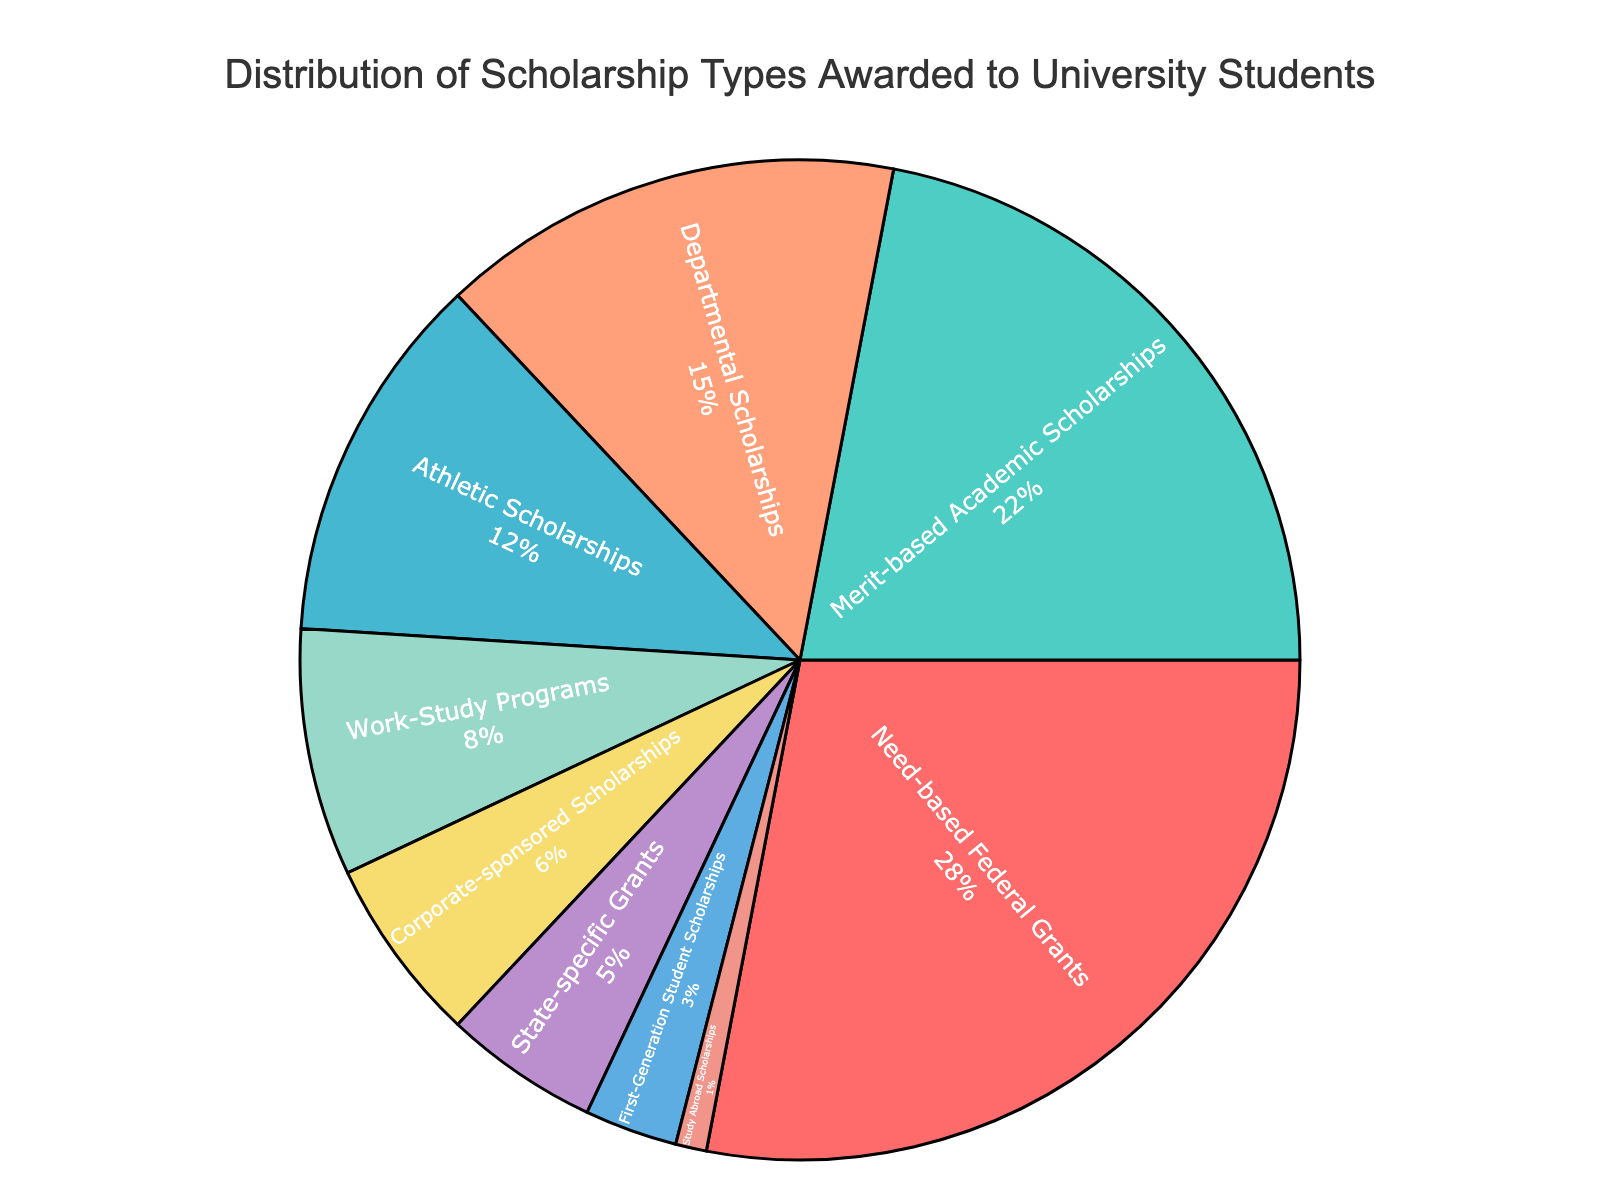What percentage of the scholarships are awarded as Need-based Federal Grants? The segment labeled "Need-based Federal Grants" shows 28% in the pie chart.
Answer: 28% Which scholarship type is the smallest in terms of percentage? The smallest segment in the pie chart is "Study Abroad Scholarships" at 1%.
Answer: Study Abroad Scholarships How much more percentage of scholarships are awarded as Merit-based Academic Scholarships compared to Athletic Scholarships? Merit-based Academic Scholarships are 22%, and Athletic Scholarships are 12%. The difference is 22% - 12% = 10%.
Answer: 10% Which scholarship types together make up exactly half of the total scholarships? Need-based Federal Grants (28%) plus Merit-based Academic Scholarships (22%) sum up to 50%.
Answer: Need-based Federal Grants and Merit-based Academic Scholarships Are there more percentage of scholarships awarded for Work-Study Programs or Corporate-Sponsored Scholarships? Work-Study Programs have 8%, while Corporate-sponsored Scholarships have 6%. Therefore, Work-Study Programs have a higher percentage.
Answer: Work-Study Programs What is the total percentage of scholarships that are Departmental, State-Specific Grants, and First-Generation Student Scholarships together? Departmental Scholarships (15%) + State-Specific Grants (5%) + First-Generation Student Scholarships (3%) = 23%.
Answer: 23% Which color represents State-Specific Grants in the pie chart? By looking at the legend associated with the colors, State-Specific Grants are represented by a purple color.
Answer: Purple What is the combined percentage for scholarships types less than 5%? State-Specific Grants (5%) + First-Generation Student Scholarships (3%) + Study Abroad Scholarships (1%) = 9%.
Answer: 9% What percentage of scholarships are non-federal (excluding Need-based Federal Grants)? Total scholarships (100%) - Need-based Federal Grants (28%) = 72%.
Answer: 72% Which two scholarship types have a combined percentage of exactly 20%? Corporate-sponsored Scholarships (6%) combined with Work-Study Programs (8%) plus Study Abroad Scholarships (1%) equals 15%; no combination of two types sums exactly to 20%.
Answer: None 